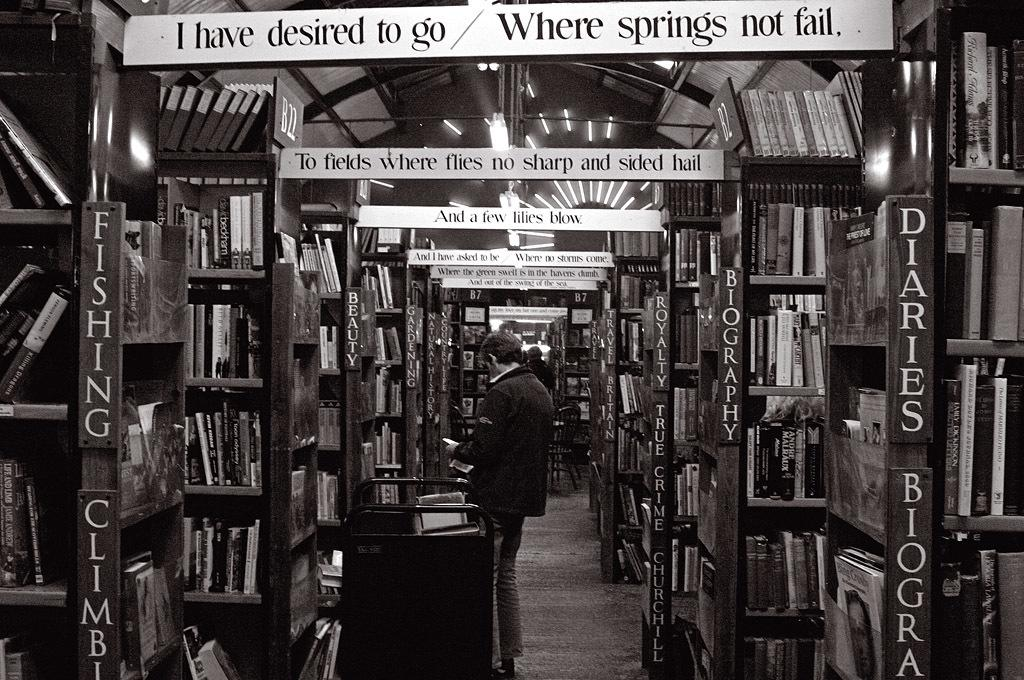<image>
Relay a brief, clear account of the picture shown. A library with a banner that says I have desired to go where springs not fail. 